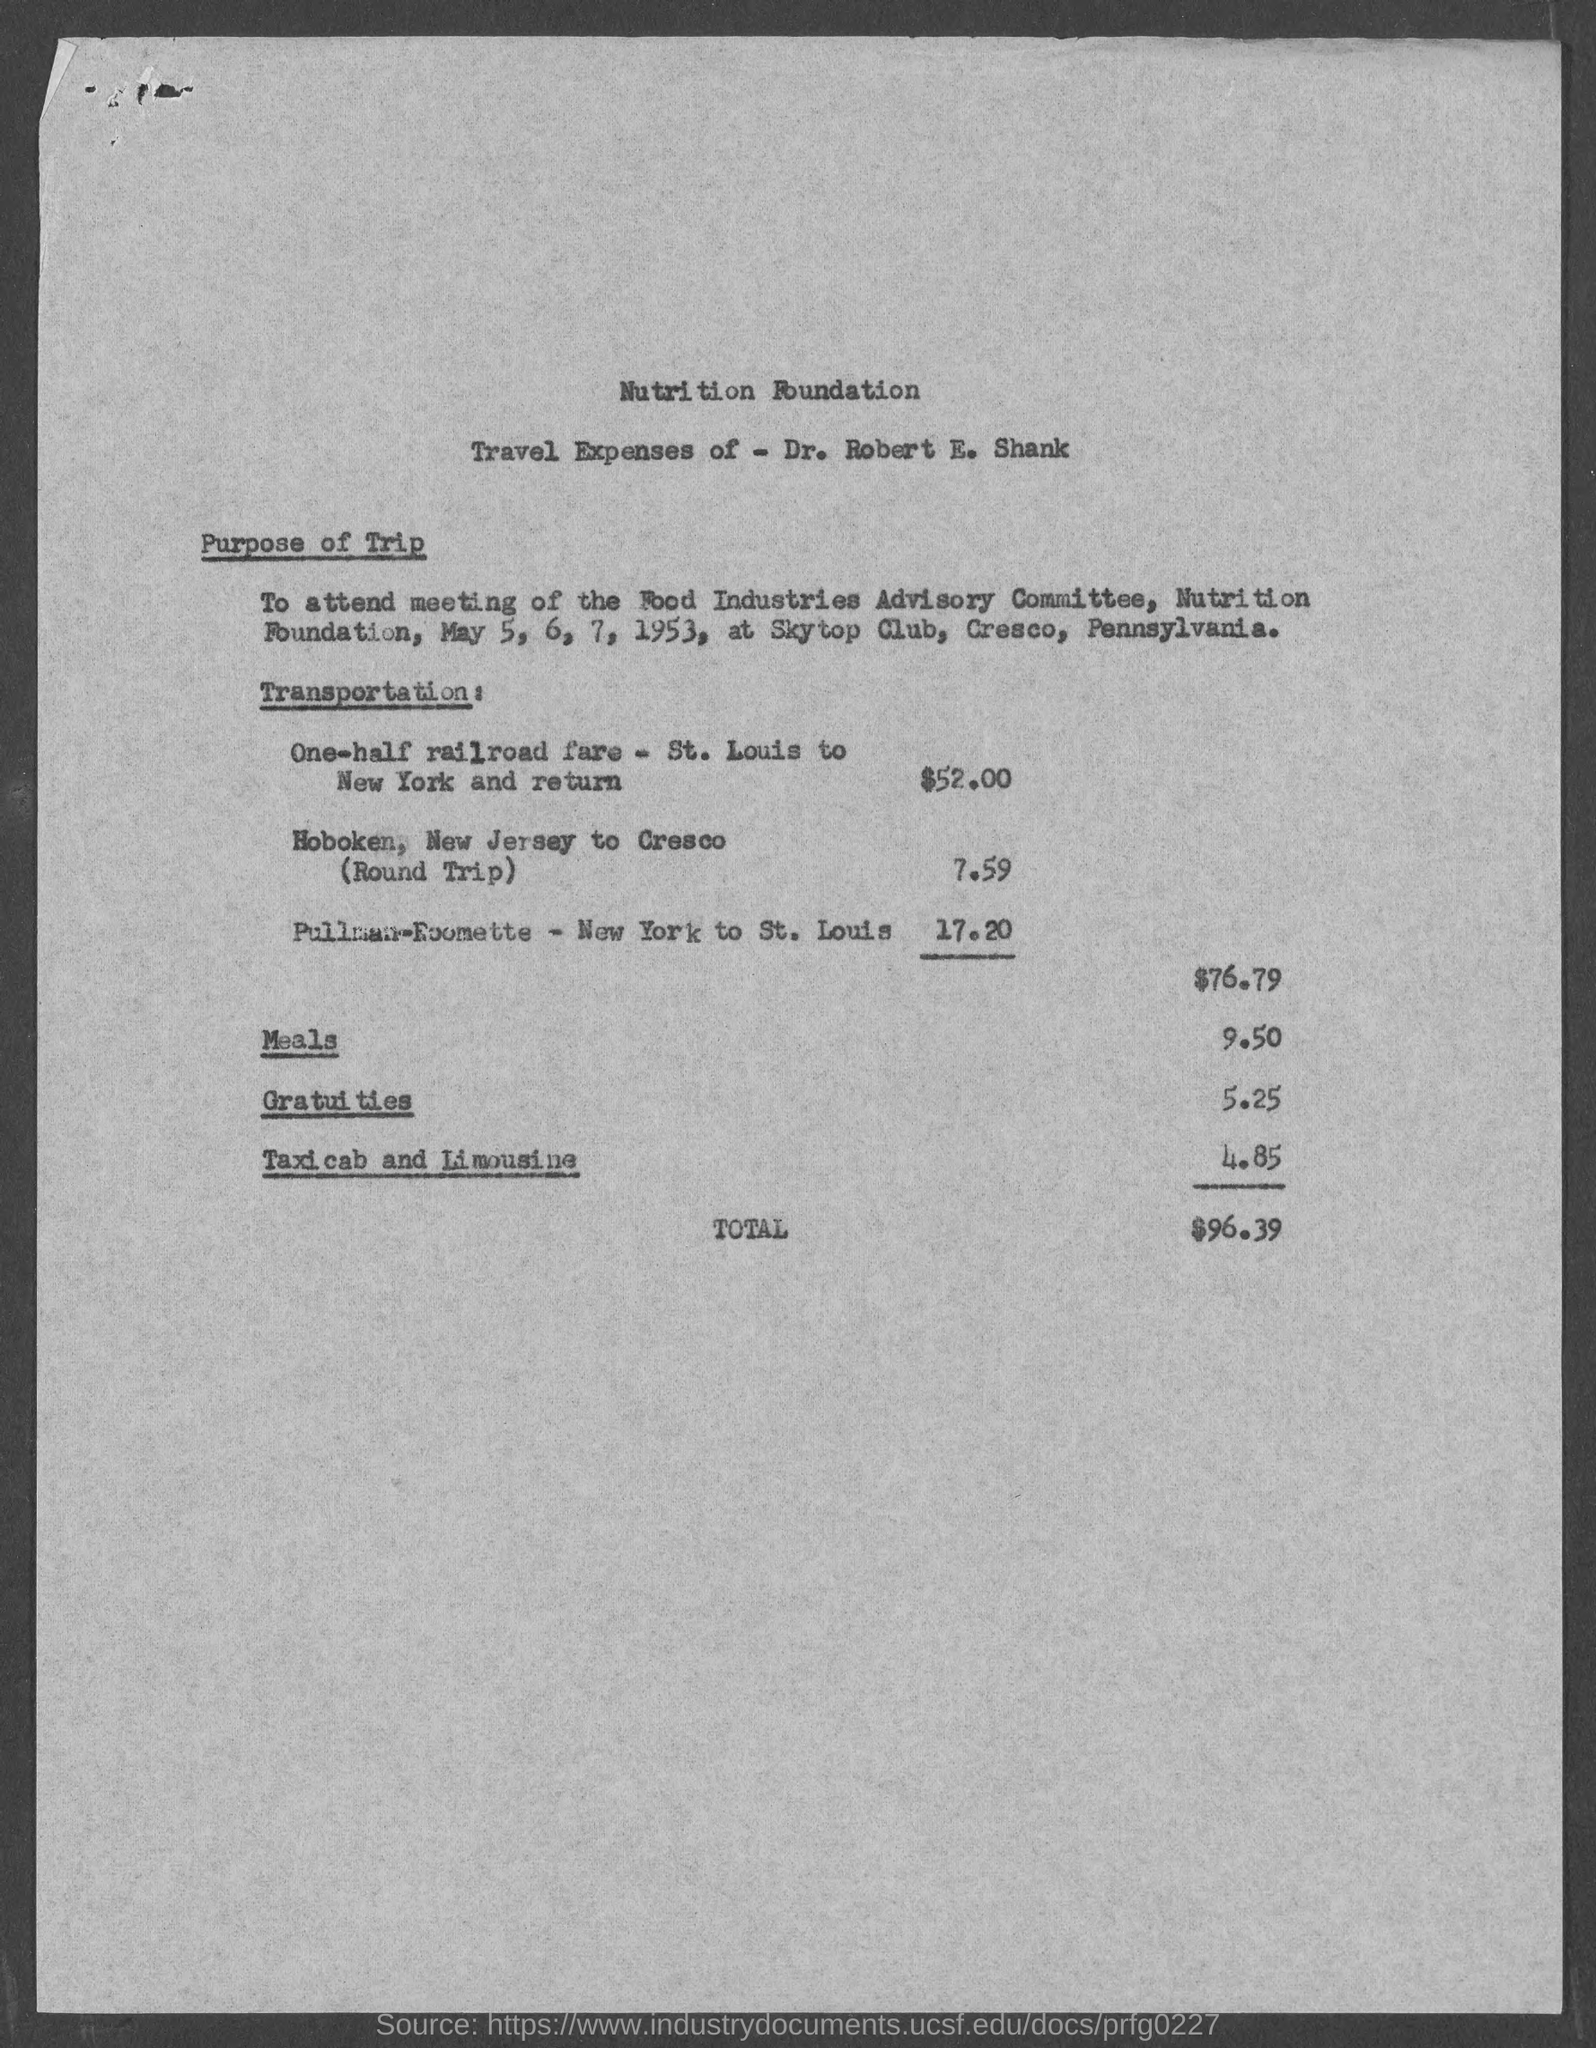What is the heading of page at top?
Keep it short and to the point. Nutrition foundation. What is one-half railroad fare- st. louis to new york and return?
Offer a terse response. $52.00. What is charge for meals?
Ensure brevity in your answer.  9.50. What is the amount spend for gratuities?
Your answer should be very brief. 5.25. What is the sum spent on taxicab and limousine?
Ensure brevity in your answer.  4.85. What is the total amount spent by dr. robert e.shank?
Offer a very short reply. $96.39. 